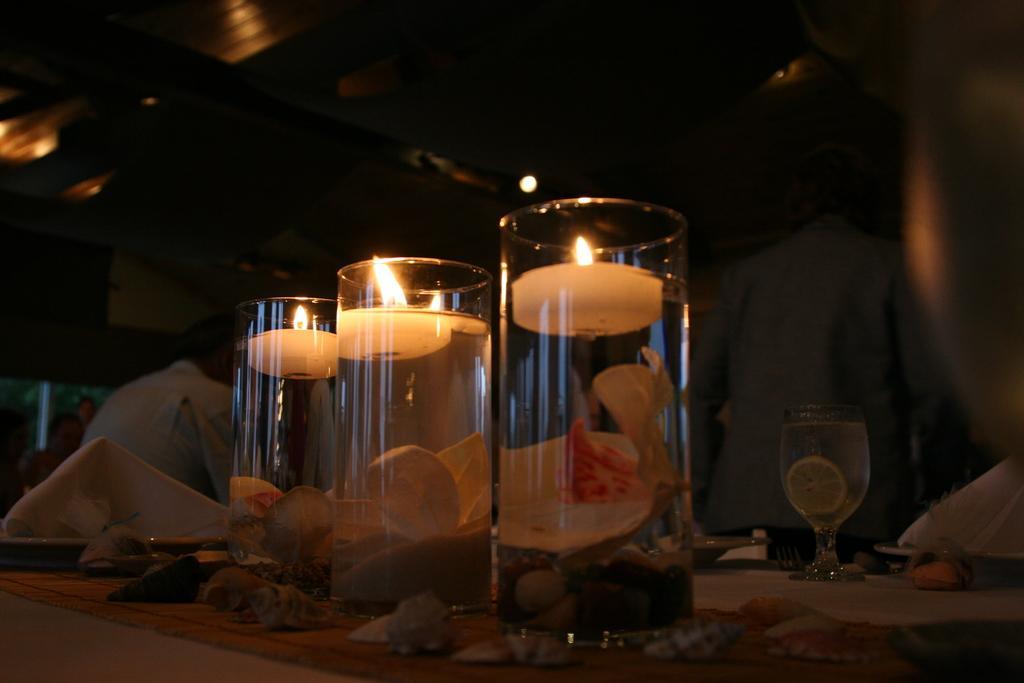Describe this image in one or two sentences. In the foreground, I can see candies, glasses and some objects on a table. In the background, I can see a group of people and lights on a rooftop. This image taken, maybe in a hotel. 